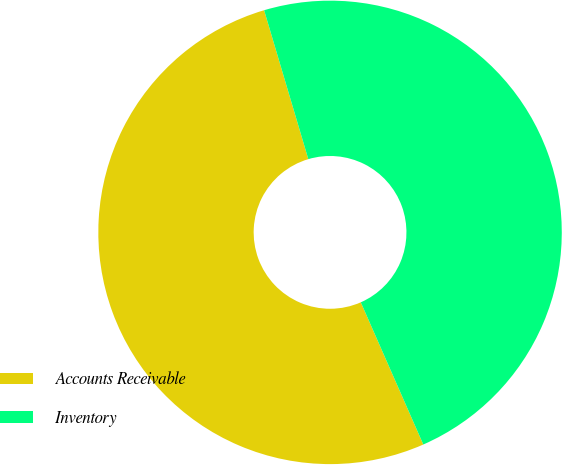<chart> <loc_0><loc_0><loc_500><loc_500><pie_chart><fcel>Accounts Receivable<fcel>Inventory<nl><fcel>52.0%<fcel>48.0%<nl></chart> 